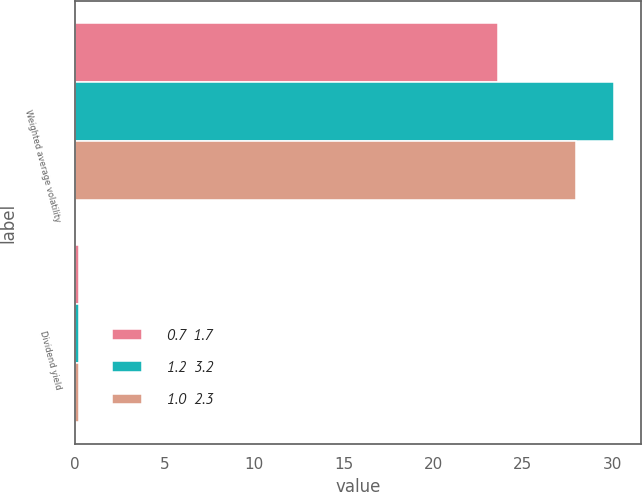Convert chart to OTSL. <chart><loc_0><loc_0><loc_500><loc_500><stacked_bar_chart><ecel><fcel>Weighted average volatility<fcel>Dividend yield<nl><fcel>0.7  1.7<fcel>23.6<fcel>0.2<nl><fcel>1.2  3.2<fcel>30.1<fcel>0.2<nl><fcel>1.0  2.3<fcel>28<fcel>0.2<nl></chart> 